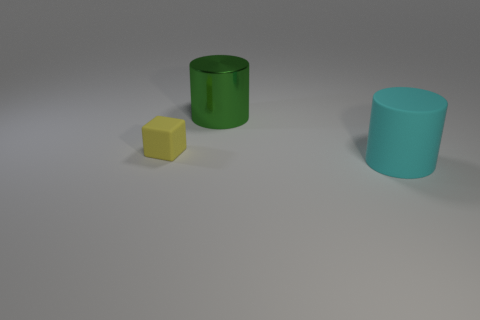The big thing that is the same material as the tiny yellow block is what shape?
Provide a short and direct response. Cylinder. Is there a cyan sphere?
Your response must be concise. No. Is the number of matte things that are in front of the block less than the number of objects left of the big cyan object?
Provide a succinct answer. Yes. There is a large object that is behind the cyan rubber thing; what is its shape?
Ensure brevity in your answer.  Cylinder. Do the cyan thing and the big green thing have the same material?
Provide a succinct answer. No. Are there any other things that have the same material as the green thing?
Ensure brevity in your answer.  No. What material is the other thing that is the same shape as the big matte thing?
Ensure brevity in your answer.  Metal. Are there fewer large green metal cylinders left of the tiny yellow thing than big green cubes?
Offer a very short reply. No. How many green things are in front of the metal object?
Give a very brief answer. 0. Do the large object behind the yellow matte thing and the large thing that is in front of the large green object have the same shape?
Provide a succinct answer. Yes. 